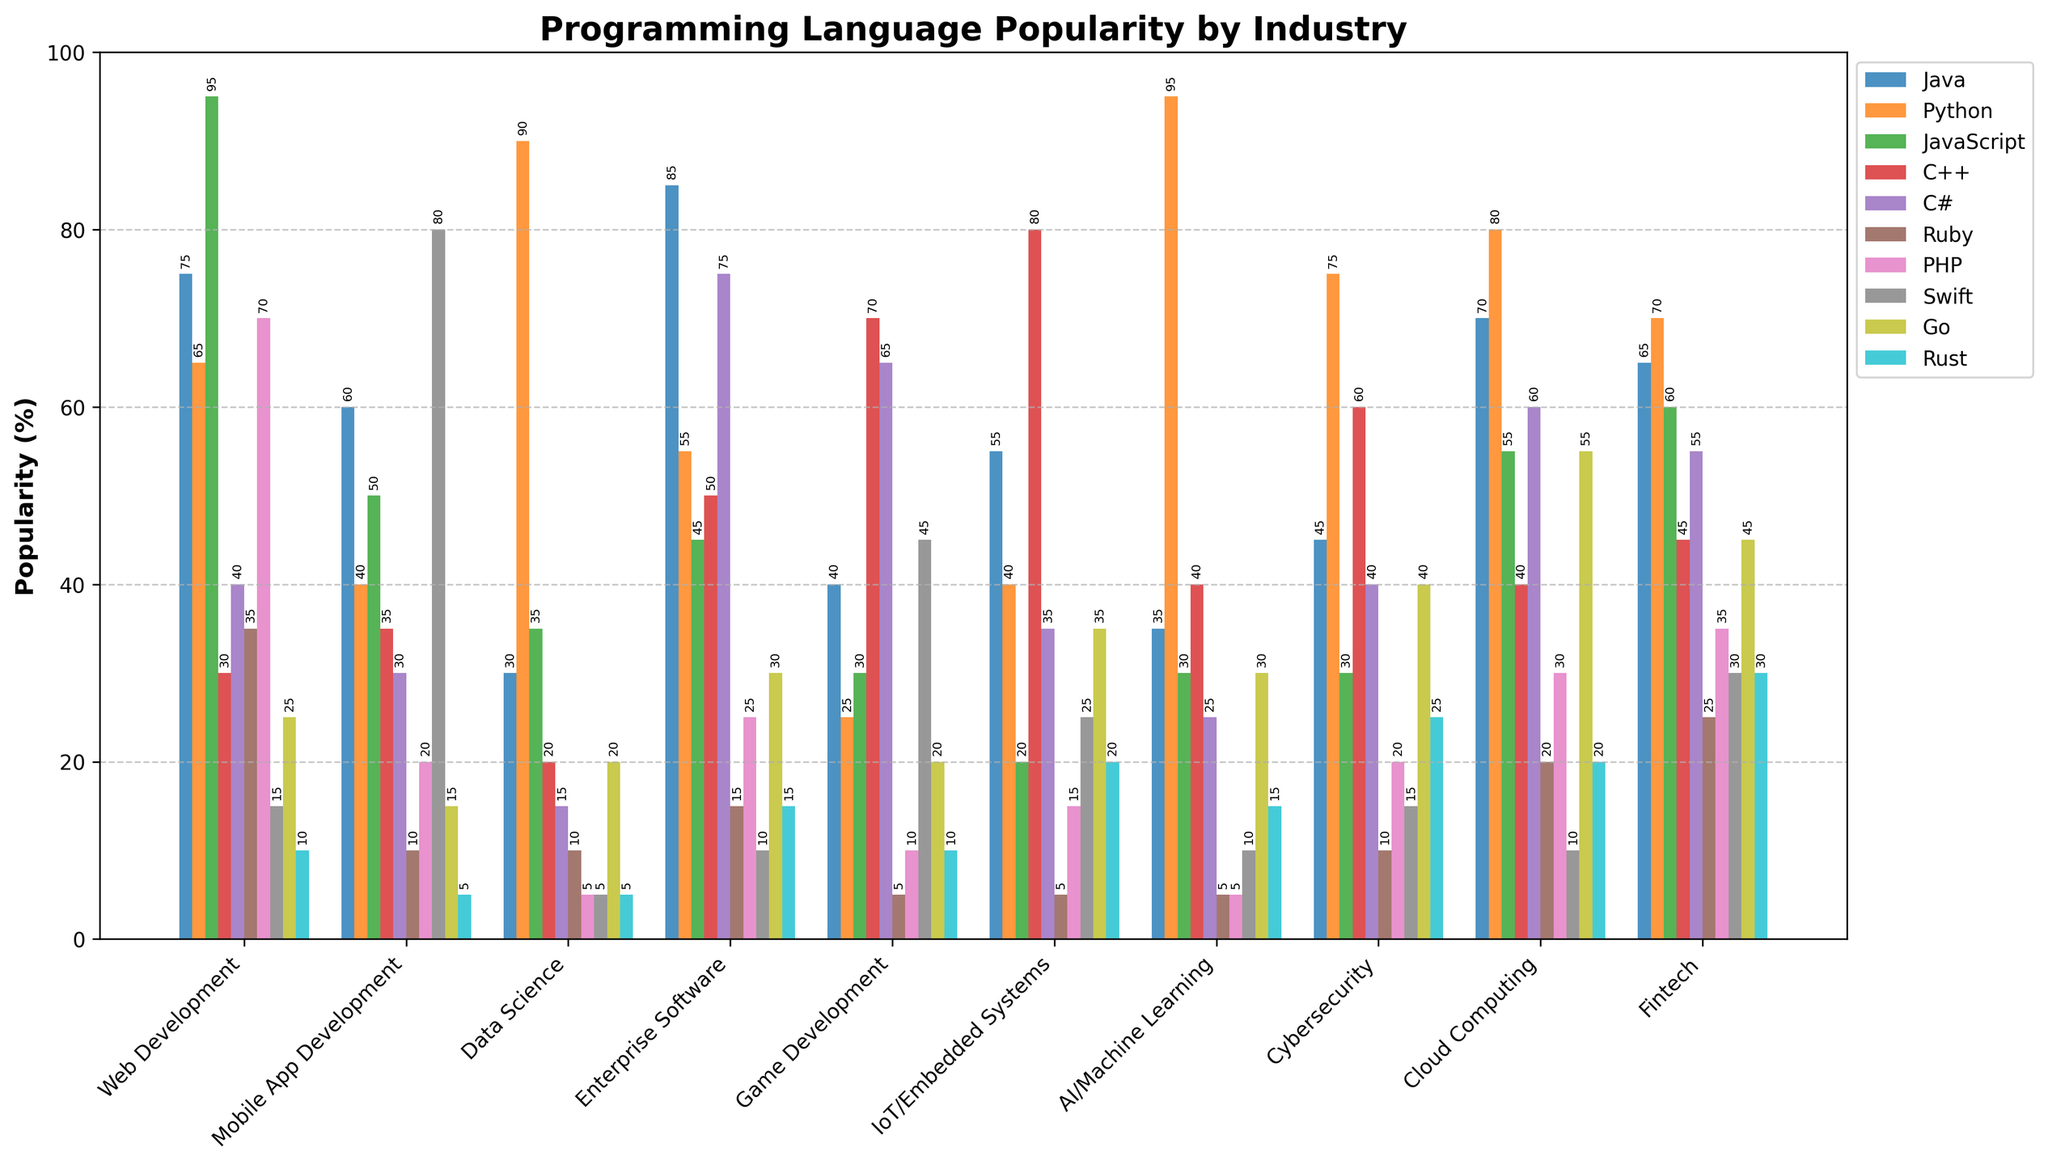Which industry uses Java the most? The bar for Enterprise Software is the tallest among all industries for Java, indicating that Java is used the most in Enterprise Software.
Answer: Enterprise Software Between Python and JavaScript, which language is more popular on average across all industries? For each language, calculate the average of the percentages across all industries. For Python: (65 + 40 + 90 + 55 + 25 + 40 + 95 + 75 + 80 + 70) / 10 = 63.5. For JavaScript: (95 + 50 + 35 + 45 + 30 + 20 + 30 + 30 + 55 + 60) / 10 = 45. JavaScript is less popular than Python on average.
Answer: Python Which industry has the highest combined popularity for C++ and C#? For each industry, add the values for C++ and C#. The industry with the highest sum is Enterprise Software with 50 (C++) + 75 (C#) = 125.
Answer: Enterprise Software Regarding Rust, which two industries have the closest popularity percentages? Compare Rust's popularity in each industry pair and find the two industries with the smallest difference. The smallest difference is between IoT/Embedded Systems and Cloud Computing (20 - 20 = 0).
Answer: IoT/Embedded Systems and Cloud Computing Is Go more popular in Cybersecurity or Fintech? The bar for Go in Cybersecurity is taller than the bar for Go in Fintech (40 vs 45).
Answer: Fintech What is the highest popularity percentage among all programming languages and industries? Identify the tallest bar in the figure. Python has the highest percentage in AI/Machine Learning with 95%.
Answer: AI/Machine Learning (Python) Which industry has the least popularity for Swift? The lowest bar for Swift is in Data Science, where its popularity is 5%.
Answer: Data Science How much more popular is Java in Web Development compared to Data Science? Subtract Data Science's percentage for Java from Web Development's percentage for Java: 75 - 30 = 45.
Answer: 45 What is the least popular programming language among all industries? The smallest bar among all the bars is for Rust in Mobile App Development, with a popularity of 5%.
Answer: Rust (Mobile App Development) 